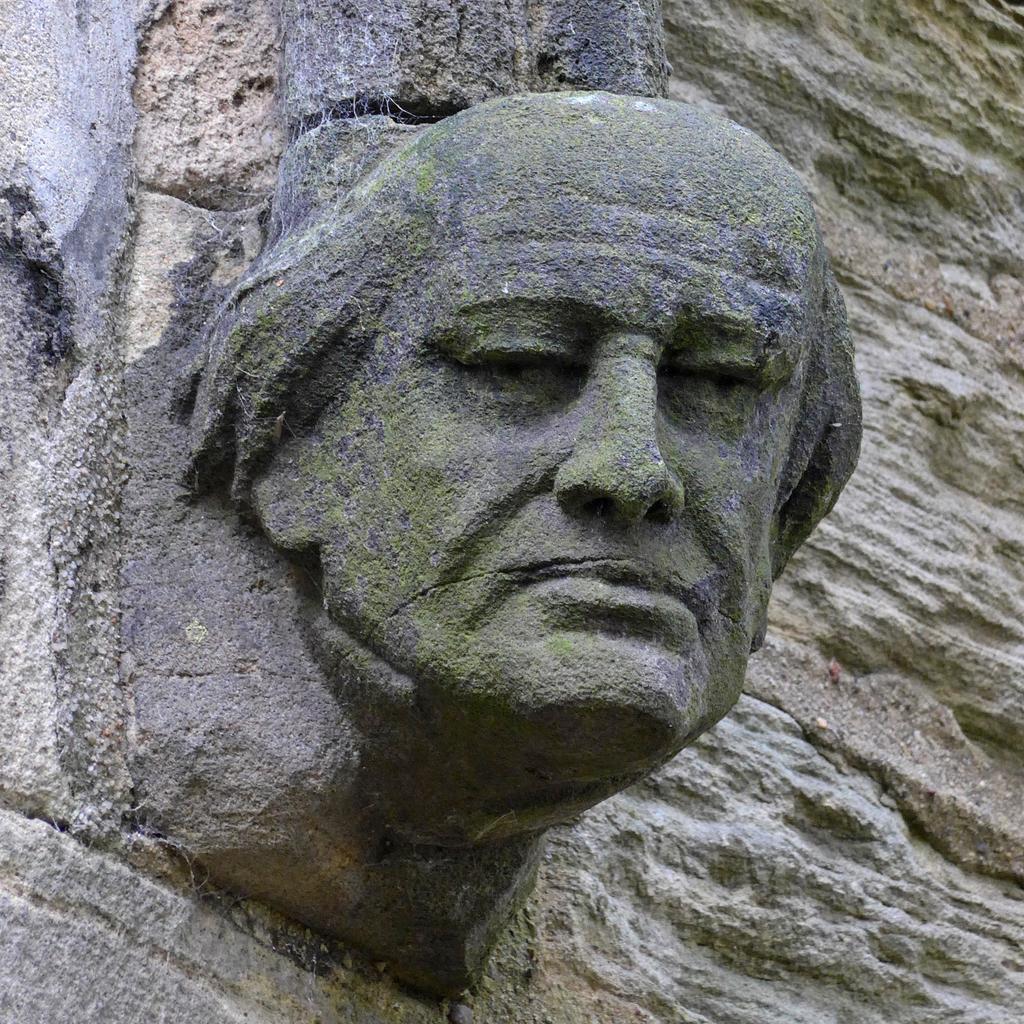Describe this image in one or two sentences. In this image we can see a depiction of a person on the rock. 